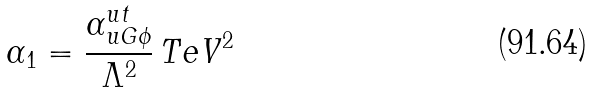<formula> <loc_0><loc_0><loc_500><loc_500>\alpha _ { 1 } = \frac { \alpha ^ { u t } _ { u G \phi } } { \Lambda ^ { 2 } } \, T e V ^ { 2 }</formula> 